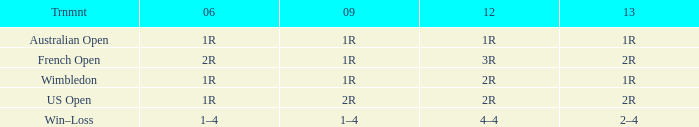What is the 2006 when the 2013 is 2r, and a Tournament was the us open? 1R. 